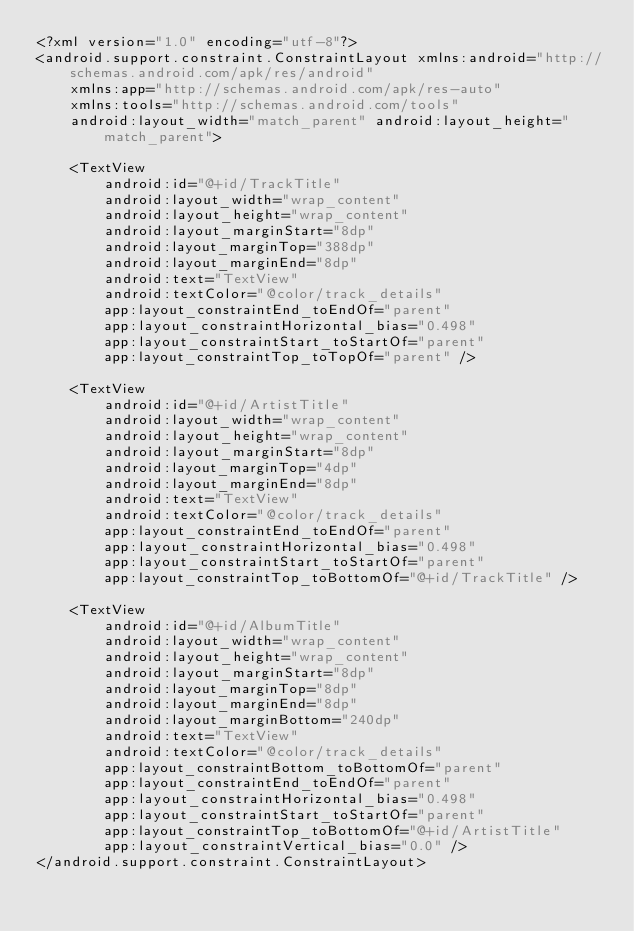<code> <loc_0><loc_0><loc_500><loc_500><_XML_><?xml version="1.0" encoding="utf-8"?>
<android.support.constraint.ConstraintLayout xmlns:android="http://schemas.android.com/apk/res/android"
    xmlns:app="http://schemas.android.com/apk/res-auto"
    xmlns:tools="http://schemas.android.com/tools"
    android:layout_width="match_parent" android:layout_height="match_parent">

    <TextView
        android:id="@+id/TrackTitle"
        android:layout_width="wrap_content"
        android:layout_height="wrap_content"
        android:layout_marginStart="8dp"
        android:layout_marginTop="388dp"
        android:layout_marginEnd="8dp"
        android:text="TextView"
        android:textColor="@color/track_details"
        app:layout_constraintEnd_toEndOf="parent"
        app:layout_constraintHorizontal_bias="0.498"
        app:layout_constraintStart_toStartOf="parent"
        app:layout_constraintTop_toTopOf="parent" />

    <TextView
        android:id="@+id/ArtistTitle"
        android:layout_width="wrap_content"
        android:layout_height="wrap_content"
        android:layout_marginStart="8dp"
        android:layout_marginTop="4dp"
        android:layout_marginEnd="8dp"
        android:text="TextView"
        android:textColor="@color/track_details"
        app:layout_constraintEnd_toEndOf="parent"
        app:layout_constraintHorizontal_bias="0.498"
        app:layout_constraintStart_toStartOf="parent"
        app:layout_constraintTop_toBottomOf="@+id/TrackTitle" />

    <TextView
        android:id="@+id/AlbumTitle"
        android:layout_width="wrap_content"
        android:layout_height="wrap_content"
        android:layout_marginStart="8dp"
        android:layout_marginTop="8dp"
        android:layout_marginEnd="8dp"
        android:layout_marginBottom="240dp"
        android:text="TextView"
        android:textColor="@color/track_details"
        app:layout_constraintBottom_toBottomOf="parent"
        app:layout_constraintEnd_toEndOf="parent"
        app:layout_constraintHorizontal_bias="0.498"
        app:layout_constraintStart_toStartOf="parent"
        app:layout_constraintTop_toBottomOf="@+id/ArtistTitle"
        app:layout_constraintVertical_bias="0.0" />
</android.support.constraint.ConstraintLayout></code> 